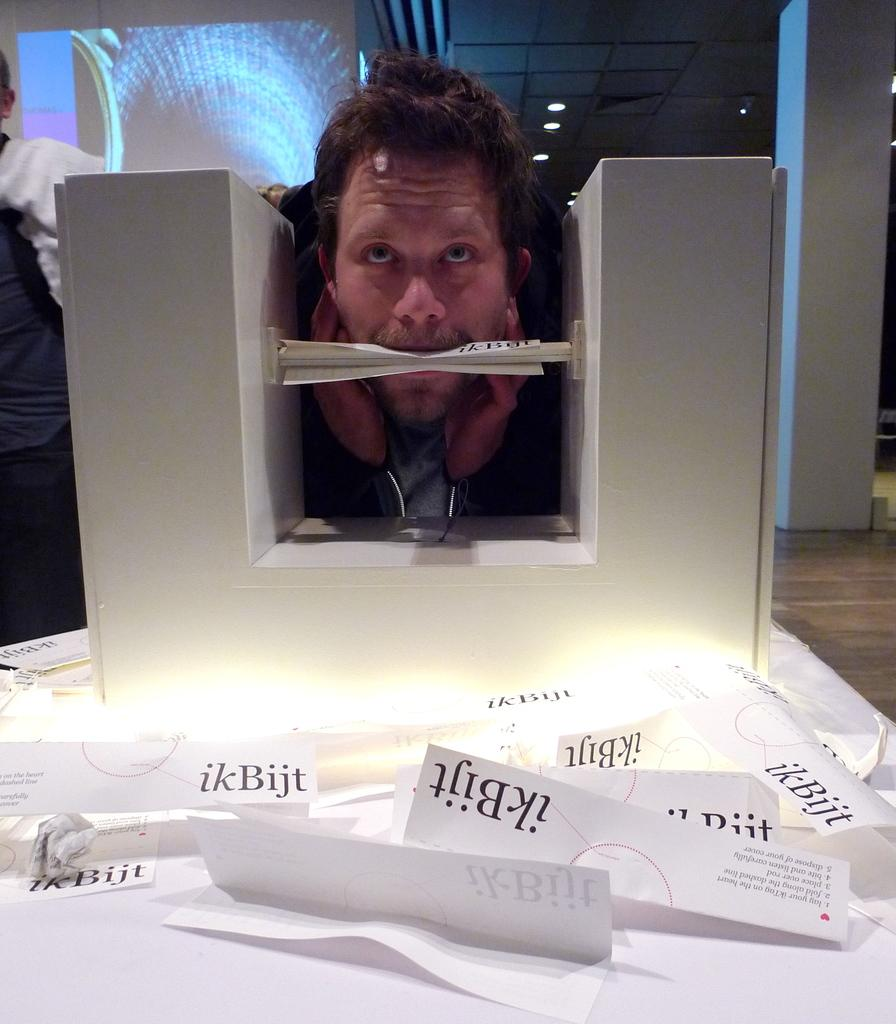<image>
Write a terse but informative summary of the picture. A man has his face in a block holding a piece of paper in his mouth while other folded up papers saying ikBijt are crumpled in front of him. 